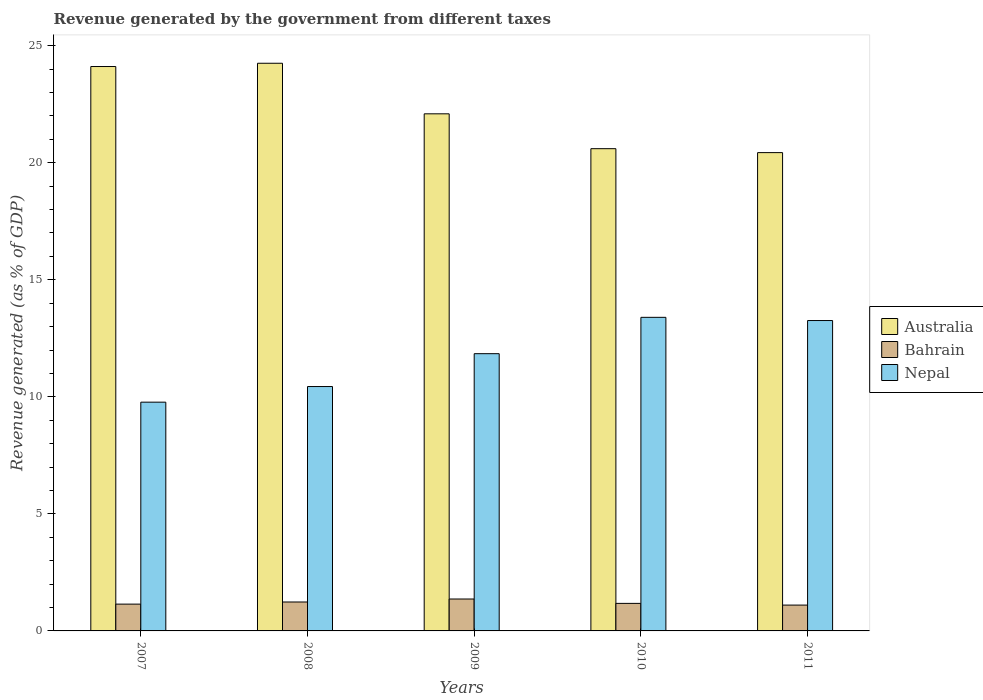How many groups of bars are there?
Your response must be concise. 5. Are the number of bars per tick equal to the number of legend labels?
Your answer should be compact. Yes. Are the number of bars on each tick of the X-axis equal?
Keep it short and to the point. Yes. How many bars are there on the 4th tick from the right?
Give a very brief answer. 3. What is the label of the 5th group of bars from the left?
Offer a terse response. 2011. What is the revenue generated by the government in Australia in 2011?
Provide a short and direct response. 20.43. Across all years, what is the maximum revenue generated by the government in Bahrain?
Your answer should be compact. 1.36. Across all years, what is the minimum revenue generated by the government in Australia?
Keep it short and to the point. 20.43. In which year was the revenue generated by the government in Nepal maximum?
Make the answer very short. 2010. What is the total revenue generated by the government in Bahrain in the graph?
Offer a terse response. 6.02. What is the difference between the revenue generated by the government in Australia in 2007 and that in 2011?
Your answer should be very brief. 3.68. What is the difference between the revenue generated by the government in Australia in 2007 and the revenue generated by the government in Nepal in 2010?
Your answer should be very brief. 10.72. What is the average revenue generated by the government in Nepal per year?
Your answer should be very brief. 11.74. In the year 2009, what is the difference between the revenue generated by the government in Bahrain and revenue generated by the government in Australia?
Offer a very short reply. -20.73. What is the ratio of the revenue generated by the government in Nepal in 2007 to that in 2011?
Keep it short and to the point. 0.74. Is the revenue generated by the government in Nepal in 2007 less than that in 2008?
Provide a succinct answer. Yes. What is the difference between the highest and the second highest revenue generated by the government in Bahrain?
Give a very brief answer. 0.13. What is the difference between the highest and the lowest revenue generated by the government in Bahrain?
Your answer should be very brief. 0.26. In how many years, is the revenue generated by the government in Bahrain greater than the average revenue generated by the government in Bahrain taken over all years?
Provide a succinct answer. 2. What does the 1st bar from the left in 2010 represents?
Your answer should be very brief. Australia. What does the 2nd bar from the right in 2009 represents?
Offer a terse response. Bahrain. How many bars are there?
Your response must be concise. 15. Are all the bars in the graph horizontal?
Your answer should be very brief. No. How many years are there in the graph?
Provide a succinct answer. 5. Does the graph contain grids?
Your response must be concise. No. Where does the legend appear in the graph?
Offer a very short reply. Center right. How many legend labels are there?
Offer a very short reply. 3. How are the legend labels stacked?
Provide a short and direct response. Vertical. What is the title of the graph?
Offer a very short reply. Revenue generated by the government from different taxes. Does "Europe(all income levels)" appear as one of the legend labels in the graph?
Your response must be concise. No. What is the label or title of the Y-axis?
Provide a short and direct response. Revenue generated (as % of GDP). What is the Revenue generated (as % of GDP) of Australia in 2007?
Your answer should be compact. 24.11. What is the Revenue generated (as % of GDP) in Bahrain in 2007?
Keep it short and to the point. 1.15. What is the Revenue generated (as % of GDP) of Nepal in 2007?
Provide a short and direct response. 9.77. What is the Revenue generated (as % of GDP) in Australia in 2008?
Make the answer very short. 24.25. What is the Revenue generated (as % of GDP) in Bahrain in 2008?
Your answer should be compact. 1.24. What is the Revenue generated (as % of GDP) in Nepal in 2008?
Keep it short and to the point. 10.44. What is the Revenue generated (as % of GDP) in Australia in 2009?
Make the answer very short. 22.09. What is the Revenue generated (as % of GDP) of Bahrain in 2009?
Your response must be concise. 1.36. What is the Revenue generated (as % of GDP) of Nepal in 2009?
Your answer should be very brief. 11.84. What is the Revenue generated (as % of GDP) of Australia in 2010?
Ensure brevity in your answer.  20.6. What is the Revenue generated (as % of GDP) of Bahrain in 2010?
Your answer should be very brief. 1.18. What is the Revenue generated (as % of GDP) in Nepal in 2010?
Make the answer very short. 13.4. What is the Revenue generated (as % of GDP) in Australia in 2011?
Your response must be concise. 20.43. What is the Revenue generated (as % of GDP) in Bahrain in 2011?
Provide a short and direct response. 1.1. What is the Revenue generated (as % of GDP) of Nepal in 2011?
Your answer should be compact. 13.26. Across all years, what is the maximum Revenue generated (as % of GDP) of Australia?
Make the answer very short. 24.25. Across all years, what is the maximum Revenue generated (as % of GDP) of Bahrain?
Your answer should be compact. 1.36. Across all years, what is the maximum Revenue generated (as % of GDP) in Nepal?
Your response must be concise. 13.4. Across all years, what is the minimum Revenue generated (as % of GDP) in Australia?
Your answer should be very brief. 20.43. Across all years, what is the minimum Revenue generated (as % of GDP) in Bahrain?
Make the answer very short. 1.1. Across all years, what is the minimum Revenue generated (as % of GDP) in Nepal?
Give a very brief answer. 9.77. What is the total Revenue generated (as % of GDP) in Australia in the graph?
Make the answer very short. 111.49. What is the total Revenue generated (as % of GDP) of Bahrain in the graph?
Provide a succinct answer. 6.02. What is the total Revenue generated (as % of GDP) of Nepal in the graph?
Offer a terse response. 58.71. What is the difference between the Revenue generated (as % of GDP) of Australia in 2007 and that in 2008?
Provide a succinct answer. -0.14. What is the difference between the Revenue generated (as % of GDP) in Bahrain in 2007 and that in 2008?
Your response must be concise. -0.09. What is the difference between the Revenue generated (as % of GDP) of Nepal in 2007 and that in 2008?
Ensure brevity in your answer.  -0.67. What is the difference between the Revenue generated (as % of GDP) in Australia in 2007 and that in 2009?
Your answer should be very brief. 2.02. What is the difference between the Revenue generated (as % of GDP) of Bahrain in 2007 and that in 2009?
Offer a terse response. -0.22. What is the difference between the Revenue generated (as % of GDP) of Nepal in 2007 and that in 2009?
Give a very brief answer. -2.07. What is the difference between the Revenue generated (as % of GDP) of Australia in 2007 and that in 2010?
Provide a succinct answer. 3.51. What is the difference between the Revenue generated (as % of GDP) of Bahrain in 2007 and that in 2010?
Offer a terse response. -0.03. What is the difference between the Revenue generated (as % of GDP) in Nepal in 2007 and that in 2010?
Your answer should be compact. -3.62. What is the difference between the Revenue generated (as % of GDP) in Australia in 2007 and that in 2011?
Keep it short and to the point. 3.68. What is the difference between the Revenue generated (as % of GDP) of Bahrain in 2007 and that in 2011?
Your answer should be compact. 0.04. What is the difference between the Revenue generated (as % of GDP) of Nepal in 2007 and that in 2011?
Your answer should be very brief. -3.49. What is the difference between the Revenue generated (as % of GDP) in Australia in 2008 and that in 2009?
Ensure brevity in your answer.  2.16. What is the difference between the Revenue generated (as % of GDP) of Bahrain in 2008 and that in 2009?
Your answer should be compact. -0.13. What is the difference between the Revenue generated (as % of GDP) of Nepal in 2008 and that in 2009?
Provide a short and direct response. -1.4. What is the difference between the Revenue generated (as % of GDP) of Australia in 2008 and that in 2010?
Offer a terse response. 3.65. What is the difference between the Revenue generated (as % of GDP) of Bahrain in 2008 and that in 2010?
Give a very brief answer. 0.06. What is the difference between the Revenue generated (as % of GDP) of Nepal in 2008 and that in 2010?
Provide a succinct answer. -2.96. What is the difference between the Revenue generated (as % of GDP) in Australia in 2008 and that in 2011?
Keep it short and to the point. 3.82. What is the difference between the Revenue generated (as % of GDP) in Bahrain in 2008 and that in 2011?
Keep it short and to the point. 0.13. What is the difference between the Revenue generated (as % of GDP) of Nepal in 2008 and that in 2011?
Keep it short and to the point. -2.82. What is the difference between the Revenue generated (as % of GDP) in Australia in 2009 and that in 2010?
Keep it short and to the point. 1.49. What is the difference between the Revenue generated (as % of GDP) in Bahrain in 2009 and that in 2010?
Keep it short and to the point. 0.19. What is the difference between the Revenue generated (as % of GDP) of Nepal in 2009 and that in 2010?
Your response must be concise. -1.55. What is the difference between the Revenue generated (as % of GDP) in Australia in 2009 and that in 2011?
Provide a short and direct response. 1.66. What is the difference between the Revenue generated (as % of GDP) in Bahrain in 2009 and that in 2011?
Offer a very short reply. 0.26. What is the difference between the Revenue generated (as % of GDP) of Nepal in 2009 and that in 2011?
Your answer should be very brief. -1.42. What is the difference between the Revenue generated (as % of GDP) in Australia in 2010 and that in 2011?
Give a very brief answer. 0.17. What is the difference between the Revenue generated (as % of GDP) in Bahrain in 2010 and that in 2011?
Ensure brevity in your answer.  0.07. What is the difference between the Revenue generated (as % of GDP) of Nepal in 2010 and that in 2011?
Give a very brief answer. 0.14. What is the difference between the Revenue generated (as % of GDP) of Australia in 2007 and the Revenue generated (as % of GDP) of Bahrain in 2008?
Give a very brief answer. 22.88. What is the difference between the Revenue generated (as % of GDP) of Australia in 2007 and the Revenue generated (as % of GDP) of Nepal in 2008?
Make the answer very short. 13.67. What is the difference between the Revenue generated (as % of GDP) in Bahrain in 2007 and the Revenue generated (as % of GDP) in Nepal in 2008?
Offer a terse response. -9.29. What is the difference between the Revenue generated (as % of GDP) in Australia in 2007 and the Revenue generated (as % of GDP) in Bahrain in 2009?
Give a very brief answer. 22.75. What is the difference between the Revenue generated (as % of GDP) of Australia in 2007 and the Revenue generated (as % of GDP) of Nepal in 2009?
Make the answer very short. 12.27. What is the difference between the Revenue generated (as % of GDP) in Bahrain in 2007 and the Revenue generated (as % of GDP) in Nepal in 2009?
Your answer should be compact. -10.7. What is the difference between the Revenue generated (as % of GDP) of Australia in 2007 and the Revenue generated (as % of GDP) of Bahrain in 2010?
Make the answer very short. 22.94. What is the difference between the Revenue generated (as % of GDP) of Australia in 2007 and the Revenue generated (as % of GDP) of Nepal in 2010?
Your response must be concise. 10.72. What is the difference between the Revenue generated (as % of GDP) of Bahrain in 2007 and the Revenue generated (as % of GDP) of Nepal in 2010?
Offer a terse response. -12.25. What is the difference between the Revenue generated (as % of GDP) in Australia in 2007 and the Revenue generated (as % of GDP) in Bahrain in 2011?
Provide a short and direct response. 23.01. What is the difference between the Revenue generated (as % of GDP) in Australia in 2007 and the Revenue generated (as % of GDP) in Nepal in 2011?
Your answer should be compact. 10.85. What is the difference between the Revenue generated (as % of GDP) of Bahrain in 2007 and the Revenue generated (as % of GDP) of Nepal in 2011?
Offer a terse response. -12.11. What is the difference between the Revenue generated (as % of GDP) of Australia in 2008 and the Revenue generated (as % of GDP) of Bahrain in 2009?
Offer a very short reply. 22.89. What is the difference between the Revenue generated (as % of GDP) in Australia in 2008 and the Revenue generated (as % of GDP) in Nepal in 2009?
Make the answer very short. 12.41. What is the difference between the Revenue generated (as % of GDP) of Bahrain in 2008 and the Revenue generated (as % of GDP) of Nepal in 2009?
Provide a succinct answer. -10.61. What is the difference between the Revenue generated (as % of GDP) of Australia in 2008 and the Revenue generated (as % of GDP) of Bahrain in 2010?
Your answer should be very brief. 23.07. What is the difference between the Revenue generated (as % of GDP) in Australia in 2008 and the Revenue generated (as % of GDP) in Nepal in 2010?
Offer a very short reply. 10.85. What is the difference between the Revenue generated (as % of GDP) in Bahrain in 2008 and the Revenue generated (as % of GDP) in Nepal in 2010?
Provide a succinct answer. -12.16. What is the difference between the Revenue generated (as % of GDP) in Australia in 2008 and the Revenue generated (as % of GDP) in Bahrain in 2011?
Offer a very short reply. 23.15. What is the difference between the Revenue generated (as % of GDP) of Australia in 2008 and the Revenue generated (as % of GDP) of Nepal in 2011?
Provide a succinct answer. 10.99. What is the difference between the Revenue generated (as % of GDP) of Bahrain in 2008 and the Revenue generated (as % of GDP) of Nepal in 2011?
Provide a succinct answer. -12.02. What is the difference between the Revenue generated (as % of GDP) in Australia in 2009 and the Revenue generated (as % of GDP) in Bahrain in 2010?
Keep it short and to the point. 20.91. What is the difference between the Revenue generated (as % of GDP) of Australia in 2009 and the Revenue generated (as % of GDP) of Nepal in 2010?
Offer a very short reply. 8.69. What is the difference between the Revenue generated (as % of GDP) of Bahrain in 2009 and the Revenue generated (as % of GDP) of Nepal in 2010?
Provide a succinct answer. -12.03. What is the difference between the Revenue generated (as % of GDP) of Australia in 2009 and the Revenue generated (as % of GDP) of Bahrain in 2011?
Keep it short and to the point. 20.99. What is the difference between the Revenue generated (as % of GDP) of Australia in 2009 and the Revenue generated (as % of GDP) of Nepal in 2011?
Keep it short and to the point. 8.83. What is the difference between the Revenue generated (as % of GDP) in Bahrain in 2009 and the Revenue generated (as % of GDP) in Nepal in 2011?
Provide a succinct answer. -11.9. What is the difference between the Revenue generated (as % of GDP) in Australia in 2010 and the Revenue generated (as % of GDP) in Bahrain in 2011?
Make the answer very short. 19.5. What is the difference between the Revenue generated (as % of GDP) in Australia in 2010 and the Revenue generated (as % of GDP) in Nepal in 2011?
Offer a terse response. 7.34. What is the difference between the Revenue generated (as % of GDP) of Bahrain in 2010 and the Revenue generated (as % of GDP) of Nepal in 2011?
Provide a succinct answer. -12.08. What is the average Revenue generated (as % of GDP) in Australia per year?
Ensure brevity in your answer.  22.3. What is the average Revenue generated (as % of GDP) in Bahrain per year?
Ensure brevity in your answer.  1.2. What is the average Revenue generated (as % of GDP) of Nepal per year?
Provide a succinct answer. 11.74. In the year 2007, what is the difference between the Revenue generated (as % of GDP) of Australia and Revenue generated (as % of GDP) of Bahrain?
Give a very brief answer. 22.97. In the year 2007, what is the difference between the Revenue generated (as % of GDP) in Australia and Revenue generated (as % of GDP) in Nepal?
Your answer should be very brief. 14.34. In the year 2007, what is the difference between the Revenue generated (as % of GDP) in Bahrain and Revenue generated (as % of GDP) in Nepal?
Give a very brief answer. -8.63. In the year 2008, what is the difference between the Revenue generated (as % of GDP) of Australia and Revenue generated (as % of GDP) of Bahrain?
Offer a very short reply. 23.01. In the year 2008, what is the difference between the Revenue generated (as % of GDP) in Australia and Revenue generated (as % of GDP) in Nepal?
Make the answer very short. 13.81. In the year 2008, what is the difference between the Revenue generated (as % of GDP) in Bahrain and Revenue generated (as % of GDP) in Nepal?
Offer a terse response. -9.2. In the year 2009, what is the difference between the Revenue generated (as % of GDP) in Australia and Revenue generated (as % of GDP) in Bahrain?
Offer a very short reply. 20.73. In the year 2009, what is the difference between the Revenue generated (as % of GDP) in Australia and Revenue generated (as % of GDP) in Nepal?
Provide a short and direct response. 10.25. In the year 2009, what is the difference between the Revenue generated (as % of GDP) of Bahrain and Revenue generated (as % of GDP) of Nepal?
Provide a short and direct response. -10.48. In the year 2010, what is the difference between the Revenue generated (as % of GDP) in Australia and Revenue generated (as % of GDP) in Bahrain?
Your answer should be compact. 19.43. In the year 2010, what is the difference between the Revenue generated (as % of GDP) of Australia and Revenue generated (as % of GDP) of Nepal?
Give a very brief answer. 7.21. In the year 2010, what is the difference between the Revenue generated (as % of GDP) in Bahrain and Revenue generated (as % of GDP) in Nepal?
Your answer should be very brief. -12.22. In the year 2011, what is the difference between the Revenue generated (as % of GDP) in Australia and Revenue generated (as % of GDP) in Bahrain?
Ensure brevity in your answer.  19.33. In the year 2011, what is the difference between the Revenue generated (as % of GDP) of Australia and Revenue generated (as % of GDP) of Nepal?
Provide a succinct answer. 7.17. In the year 2011, what is the difference between the Revenue generated (as % of GDP) of Bahrain and Revenue generated (as % of GDP) of Nepal?
Your answer should be compact. -12.16. What is the ratio of the Revenue generated (as % of GDP) in Australia in 2007 to that in 2008?
Ensure brevity in your answer.  0.99. What is the ratio of the Revenue generated (as % of GDP) of Bahrain in 2007 to that in 2008?
Give a very brief answer. 0.93. What is the ratio of the Revenue generated (as % of GDP) in Nepal in 2007 to that in 2008?
Provide a succinct answer. 0.94. What is the ratio of the Revenue generated (as % of GDP) in Australia in 2007 to that in 2009?
Your answer should be compact. 1.09. What is the ratio of the Revenue generated (as % of GDP) in Bahrain in 2007 to that in 2009?
Provide a succinct answer. 0.84. What is the ratio of the Revenue generated (as % of GDP) of Nepal in 2007 to that in 2009?
Offer a terse response. 0.83. What is the ratio of the Revenue generated (as % of GDP) of Australia in 2007 to that in 2010?
Your answer should be very brief. 1.17. What is the ratio of the Revenue generated (as % of GDP) of Bahrain in 2007 to that in 2010?
Your response must be concise. 0.97. What is the ratio of the Revenue generated (as % of GDP) in Nepal in 2007 to that in 2010?
Your answer should be very brief. 0.73. What is the ratio of the Revenue generated (as % of GDP) of Australia in 2007 to that in 2011?
Keep it short and to the point. 1.18. What is the ratio of the Revenue generated (as % of GDP) of Bahrain in 2007 to that in 2011?
Offer a terse response. 1.04. What is the ratio of the Revenue generated (as % of GDP) of Nepal in 2007 to that in 2011?
Your answer should be compact. 0.74. What is the ratio of the Revenue generated (as % of GDP) of Australia in 2008 to that in 2009?
Ensure brevity in your answer.  1.1. What is the ratio of the Revenue generated (as % of GDP) of Bahrain in 2008 to that in 2009?
Offer a terse response. 0.91. What is the ratio of the Revenue generated (as % of GDP) of Nepal in 2008 to that in 2009?
Offer a terse response. 0.88. What is the ratio of the Revenue generated (as % of GDP) of Australia in 2008 to that in 2010?
Offer a very short reply. 1.18. What is the ratio of the Revenue generated (as % of GDP) in Bahrain in 2008 to that in 2010?
Make the answer very short. 1.05. What is the ratio of the Revenue generated (as % of GDP) of Nepal in 2008 to that in 2010?
Your answer should be compact. 0.78. What is the ratio of the Revenue generated (as % of GDP) in Australia in 2008 to that in 2011?
Make the answer very short. 1.19. What is the ratio of the Revenue generated (as % of GDP) in Bahrain in 2008 to that in 2011?
Provide a short and direct response. 1.12. What is the ratio of the Revenue generated (as % of GDP) of Nepal in 2008 to that in 2011?
Make the answer very short. 0.79. What is the ratio of the Revenue generated (as % of GDP) of Australia in 2009 to that in 2010?
Your answer should be compact. 1.07. What is the ratio of the Revenue generated (as % of GDP) in Bahrain in 2009 to that in 2010?
Give a very brief answer. 1.16. What is the ratio of the Revenue generated (as % of GDP) in Nepal in 2009 to that in 2010?
Ensure brevity in your answer.  0.88. What is the ratio of the Revenue generated (as % of GDP) of Australia in 2009 to that in 2011?
Give a very brief answer. 1.08. What is the ratio of the Revenue generated (as % of GDP) of Bahrain in 2009 to that in 2011?
Provide a succinct answer. 1.23. What is the ratio of the Revenue generated (as % of GDP) of Nepal in 2009 to that in 2011?
Offer a very short reply. 0.89. What is the ratio of the Revenue generated (as % of GDP) in Australia in 2010 to that in 2011?
Provide a short and direct response. 1.01. What is the ratio of the Revenue generated (as % of GDP) of Bahrain in 2010 to that in 2011?
Offer a terse response. 1.07. What is the ratio of the Revenue generated (as % of GDP) of Nepal in 2010 to that in 2011?
Give a very brief answer. 1.01. What is the difference between the highest and the second highest Revenue generated (as % of GDP) of Australia?
Offer a very short reply. 0.14. What is the difference between the highest and the second highest Revenue generated (as % of GDP) of Bahrain?
Make the answer very short. 0.13. What is the difference between the highest and the second highest Revenue generated (as % of GDP) of Nepal?
Your answer should be compact. 0.14. What is the difference between the highest and the lowest Revenue generated (as % of GDP) in Australia?
Give a very brief answer. 3.82. What is the difference between the highest and the lowest Revenue generated (as % of GDP) in Bahrain?
Keep it short and to the point. 0.26. What is the difference between the highest and the lowest Revenue generated (as % of GDP) in Nepal?
Your answer should be very brief. 3.62. 